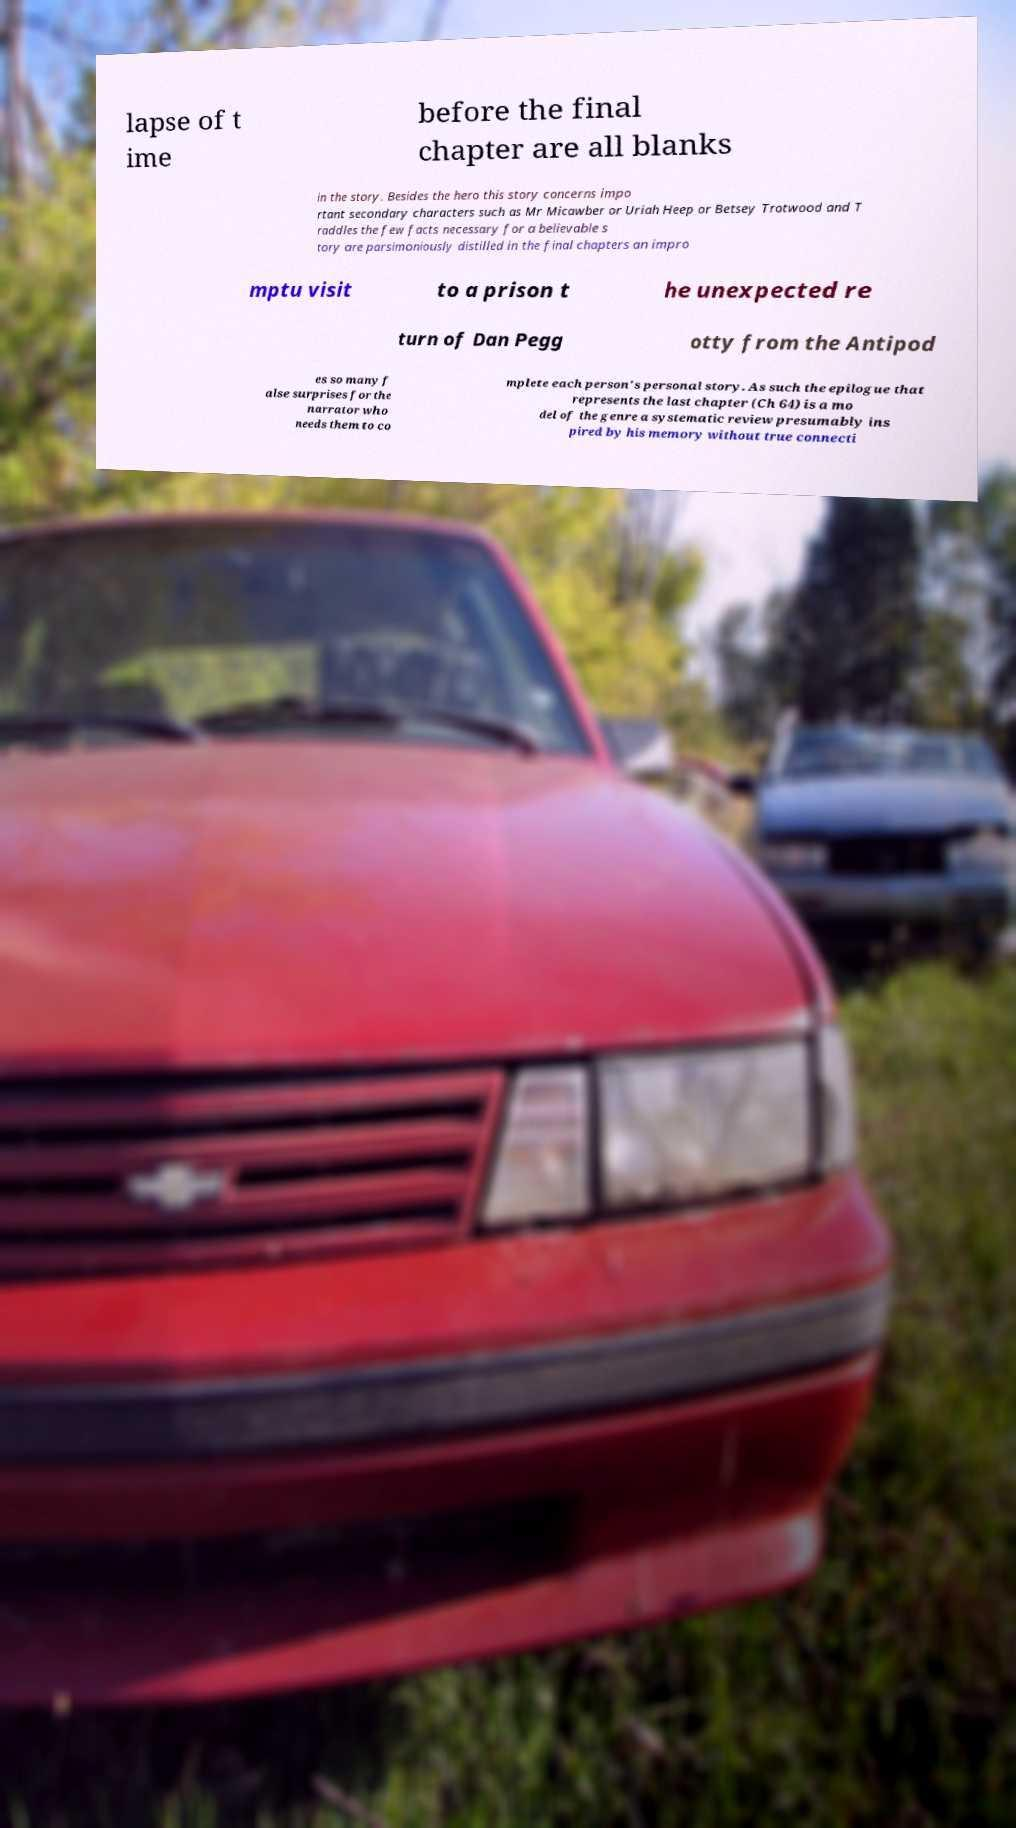I need the written content from this picture converted into text. Can you do that? lapse of t ime before the final chapter are all blanks in the story. Besides the hero this story concerns impo rtant secondary characters such as Mr Micawber or Uriah Heep or Betsey Trotwood and T raddles the few facts necessary for a believable s tory are parsimoniously distilled in the final chapters an impro mptu visit to a prison t he unexpected re turn of Dan Pegg otty from the Antipod es so many f alse surprises for the narrator who needs them to co mplete each person's personal story. As such the epilogue that represents the last chapter (Ch 64) is a mo del of the genre a systematic review presumably ins pired by his memory without true connecti 